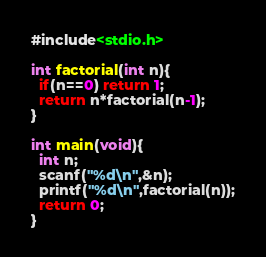<code> <loc_0><loc_0><loc_500><loc_500><_C_>#include<stdio.h>

int factorial(int n){
  if(n==0) return 1;
  return n*factorial(n-1);
}

int main(void){
  int n;
  scanf("%d\n",&n);
  printf("%d\n",factorial(n));
  return 0;
}

</code> 